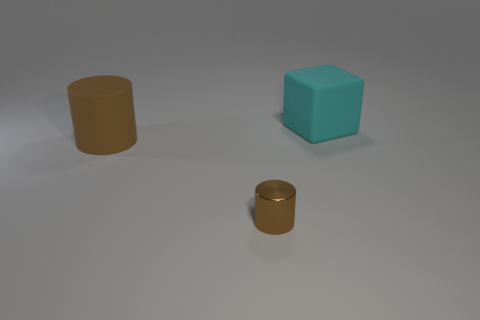What shape is the thing that is the same color as the small metallic cylinder?
Give a very brief answer. Cylinder. What number of small things are either green cubes or cyan rubber blocks?
Offer a terse response. 0. How big is the shiny thing?
Provide a short and direct response. Small. There is a metal thing; is it the same size as the matte thing to the right of the tiny brown metal object?
Provide a short and direct response. No. What number of cyan things are either big matte things or matte cylinders?
Give a very brief answer. 1. What number of rubber spheres are there?
Offer a terse response. 0. What size is the matte object in front of the cyan matte object?
Offer a terse response. Large. Is the size of the rubber cube the same as the brown matte object?
Your answer should be very brief. Yes. How many things are either green rubber things or small brown metallic things in front of the cube?
Offer a terse response. 1. What material is the large brown thing?
Your answer should be very brief. Rubber. 